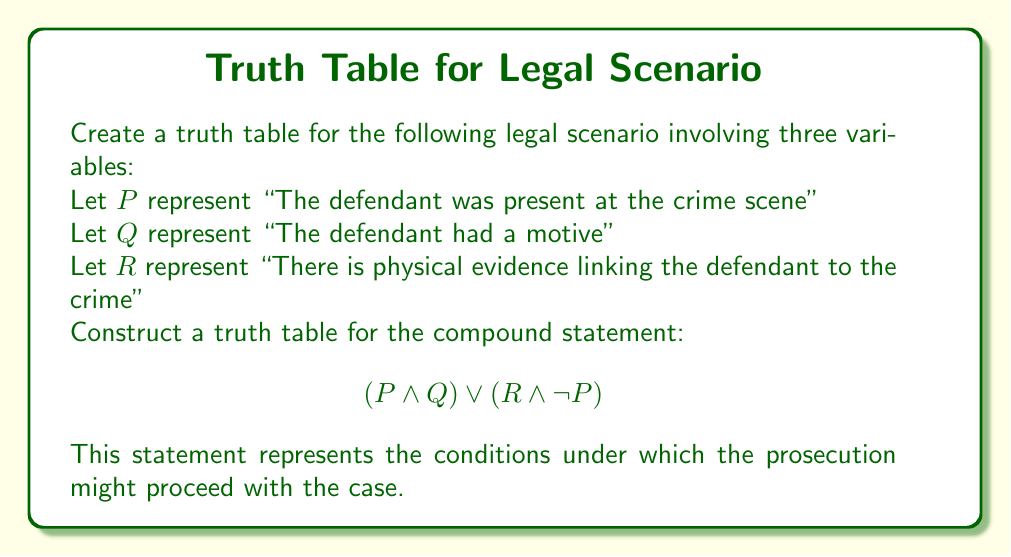Help me with this question. To create a truth table for this scenario, we need to follow these steps:

1. Identify the variables: P, Q, and R
2. List all possible combinations of truth values for these variables
3. Evaluate the sub-expressions: $(P \land Q)$ and $(R \land \lnot P)$
4. Evaluate the final expression: $(P \land Q) \lor (R \land \lnot P)$

Step 1: The variables are already identified.

Step 2: With 3 variables, we have $2^3 = 8$ possible combinations:

| P | Q | R |
|---|---|---|
| T | T | T |
| T | T | F |
| T | F | T |
| T | F | F |
| F | T | T |
| F | T | F |
| F | F | T |
| F | F | F |

Step 3: Evaluate sub-expressions

For $(P \land Q)$:
- True only when both P and Q are true

For $(R \land \lnot P)$:
- True when R is true and P is false

Step 4: Evaluate the final expression

| P | Q | R | $P \land Q$ | $\lnot P$ | $R \land \lnot P$ | $(P \land Q) \lor (R \land \lnot P)$ |
|---|---|---|-------------|-----------|-------------------|---------------------------------------|
| T | T | T | T           | F         | F                 | T                                     |
| T | T | F | T           | F         | F                 | T                                     |
| T | F | T | F           | F         | F                 | F                                     |
| T | F | F | F           | F         | F                 | F                                     |
| F | T | T | F           | T         | T                 | T                                     |
| F | T | F | F           | T         | F                 | F                                     |
| F | F | T | F           | T         | T                 | T                                     |
| F | F | F | F           | T         | F                 | F                                     |

The final column represents the truth values for the entire expression.
Answer: $$\begin{array}{|c|c|c|c|}
\hline
P & Q & R & (P \land Q) \lor (R \land \lnot P) \\
\hline
T & T & T & T \\
T & T & F & T \\
T & F & T & F \\
T & F & F & F \\
F & T & T & T \\
F & T & F & F \\
F & F & T & T \\
F & F & F & F \\
\hline
\end{array}$$ 